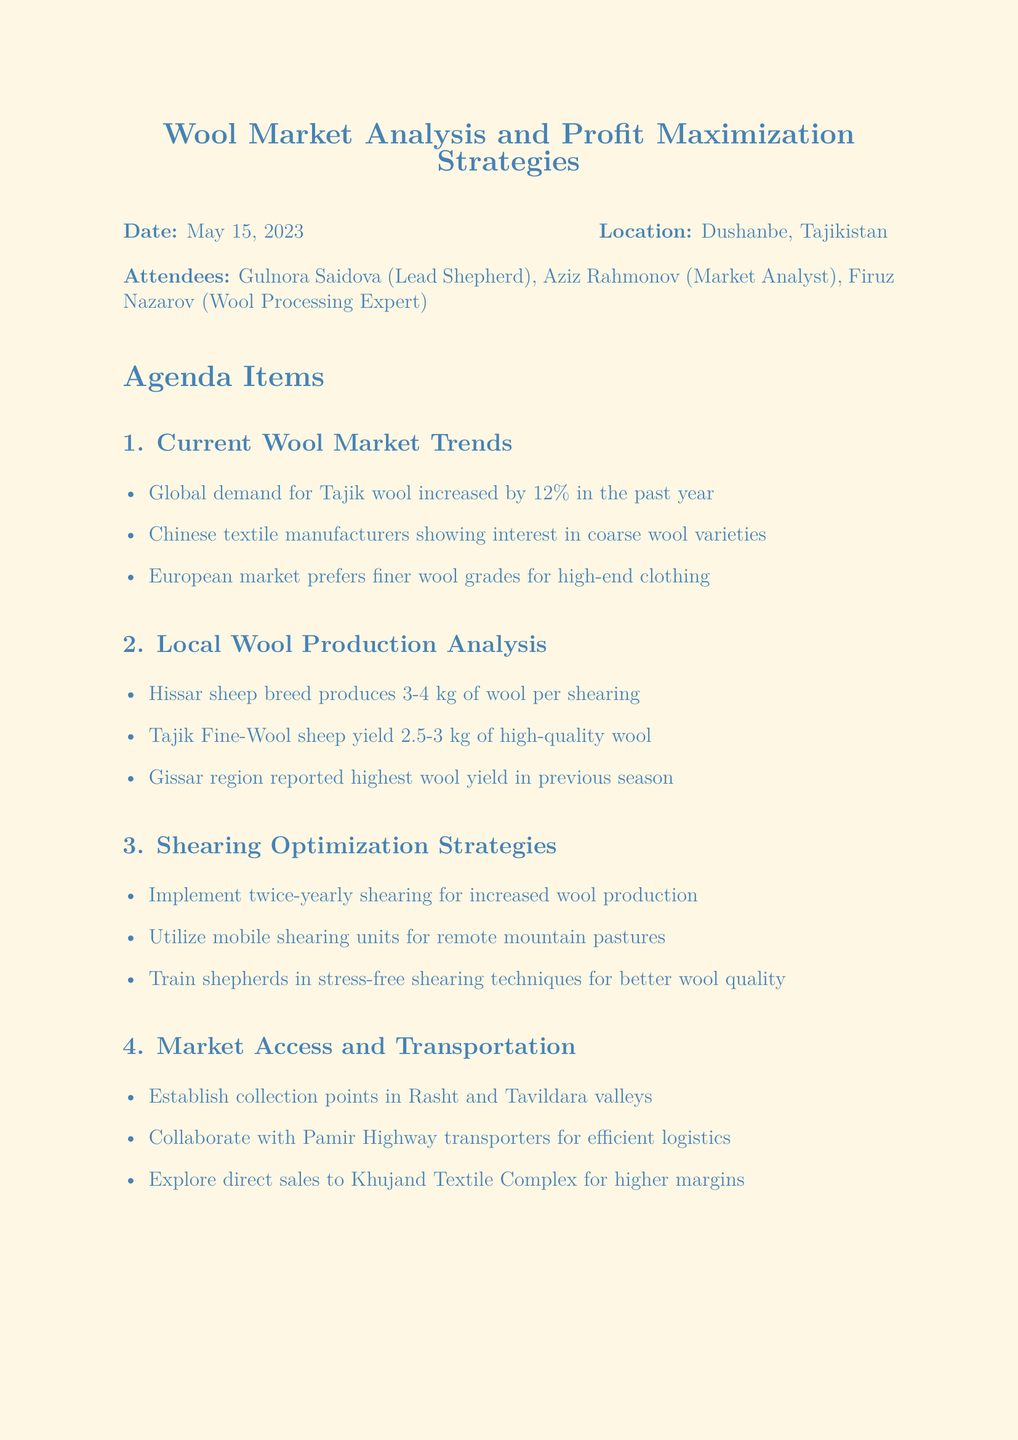what was the date of the meeting? The date of the meeting is specified in the document as May 15, 2023.
Answer: May 15, 2023 who is the Lead Shepherd mentioned in the meeting? The document lists Gulnora Saidova as the Lead Shepherd attending the meeting.
Answer: Gulnora Saidova what was the increase in global demand for Tajik wool in the past year? The document states that the global demand for Tajik wool increased by 12 percent.
Answer: 12% how much wool does the Hissar sheep breed produce per shearing? The document provides that the Hissar sheep breed produces 3-4 kg of wool per shearing.
Answer: 3-4 kg what is one of the key strategies for shearing optimization mentioned? The document lists several strategies, one of which is to implement twice-yearly shearing for increased wool production.
Answer: Implement twice-yearly shearing which region reported the highest wool yield in the previous season? The document indicates that the Gissar region reported the highest wool yield in the previous season.
Answer: Gissar region what are the proposed collection points for wool in the document? The document specifies establishing collection points in Rasht and Tavildara valleys.
Answer: Rasht and Tavildara valleys what was one action item decided in the meeting? The document includes multiple action items, including conducting a feasibility study for mobile shearing units.
Answer: Conduct feasibility study for mobile shearing units 